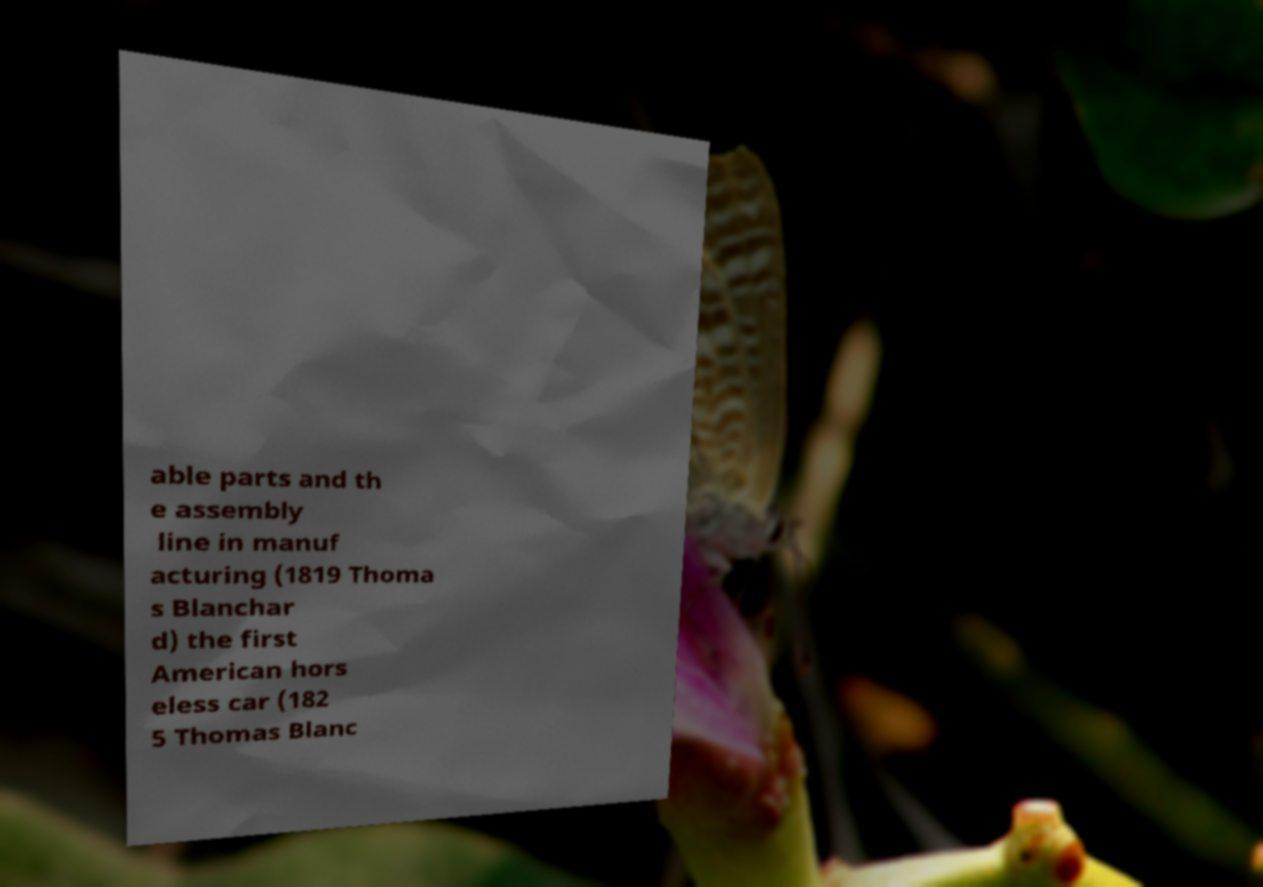Could you extract and type out the text from this image? able parts and th e assembly line in manuf acturing (1819 Thoma s Blanchar d) the first American hors eless car (182 5 Thomas Blanc 